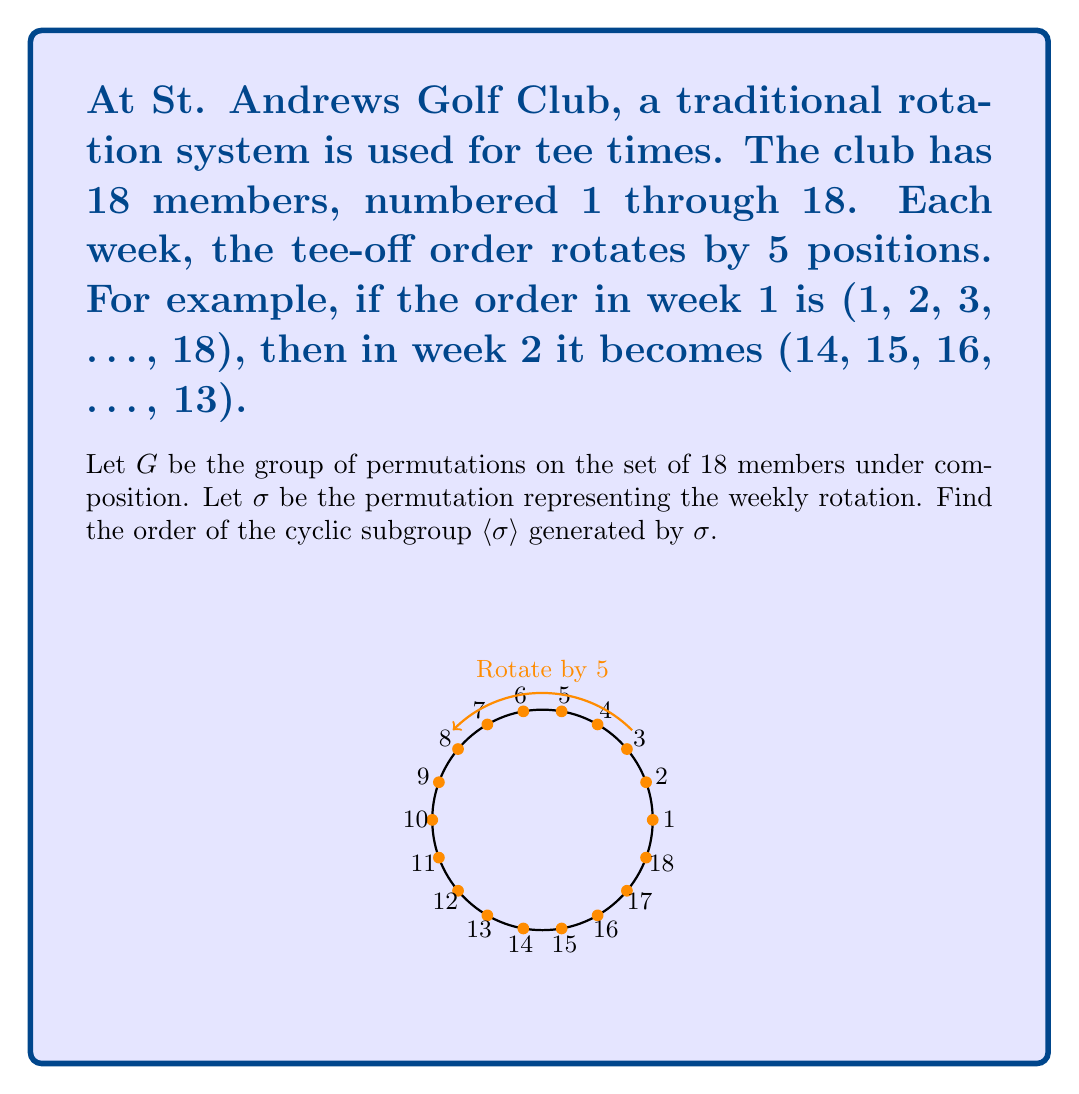Provide a solution to this math problem. Let's approach this step-by-step:

1) First, we need to understand what $\sigma$ does. It shifts each member's position by 5 (mod 18). In cycle notation:
   $\sigma = (1 \, 6 \, 11 \, 16 \, 3 \, 8 \, 13 \, 18 \, 5 \, 10 \, 15 \, 2 \, 7 \, 12 \, 17 \, 4 \, 9 \, 14)$

2) The order of $\langle \sigma \rangle$ is the smallest positive integer $n$ such that $\sigma^n = e$ (the identity permutation).

3) To find this, we need to determine how many applications of $\sigma$ it takes to return each element to its original position.

4) We can calculate this using the concept of modular arithmetic. We're essentially looking for the smallest positive $n$ such that:
   $5n \equiv 0 \pmod{18}$

5) This is equivalent to solving the linear congruence:
   $5n \equiv 0 \pmod{18}$

6) To solve this, we first find $\gcd(5,18) = 1$. Since the GCD is 1, the smallest solution will be when $n$ is equal to the modulus 18.

7) We can verify:
   $5 \cdot 18 = 90 \equiv 0 \pmod{18}$

8) Therefore, it takes 18 rotations to return to the original order.

9) This means that the order of the cyclic subgroup $\langle \sigma \rangle$ is 18.
Answer: 18 